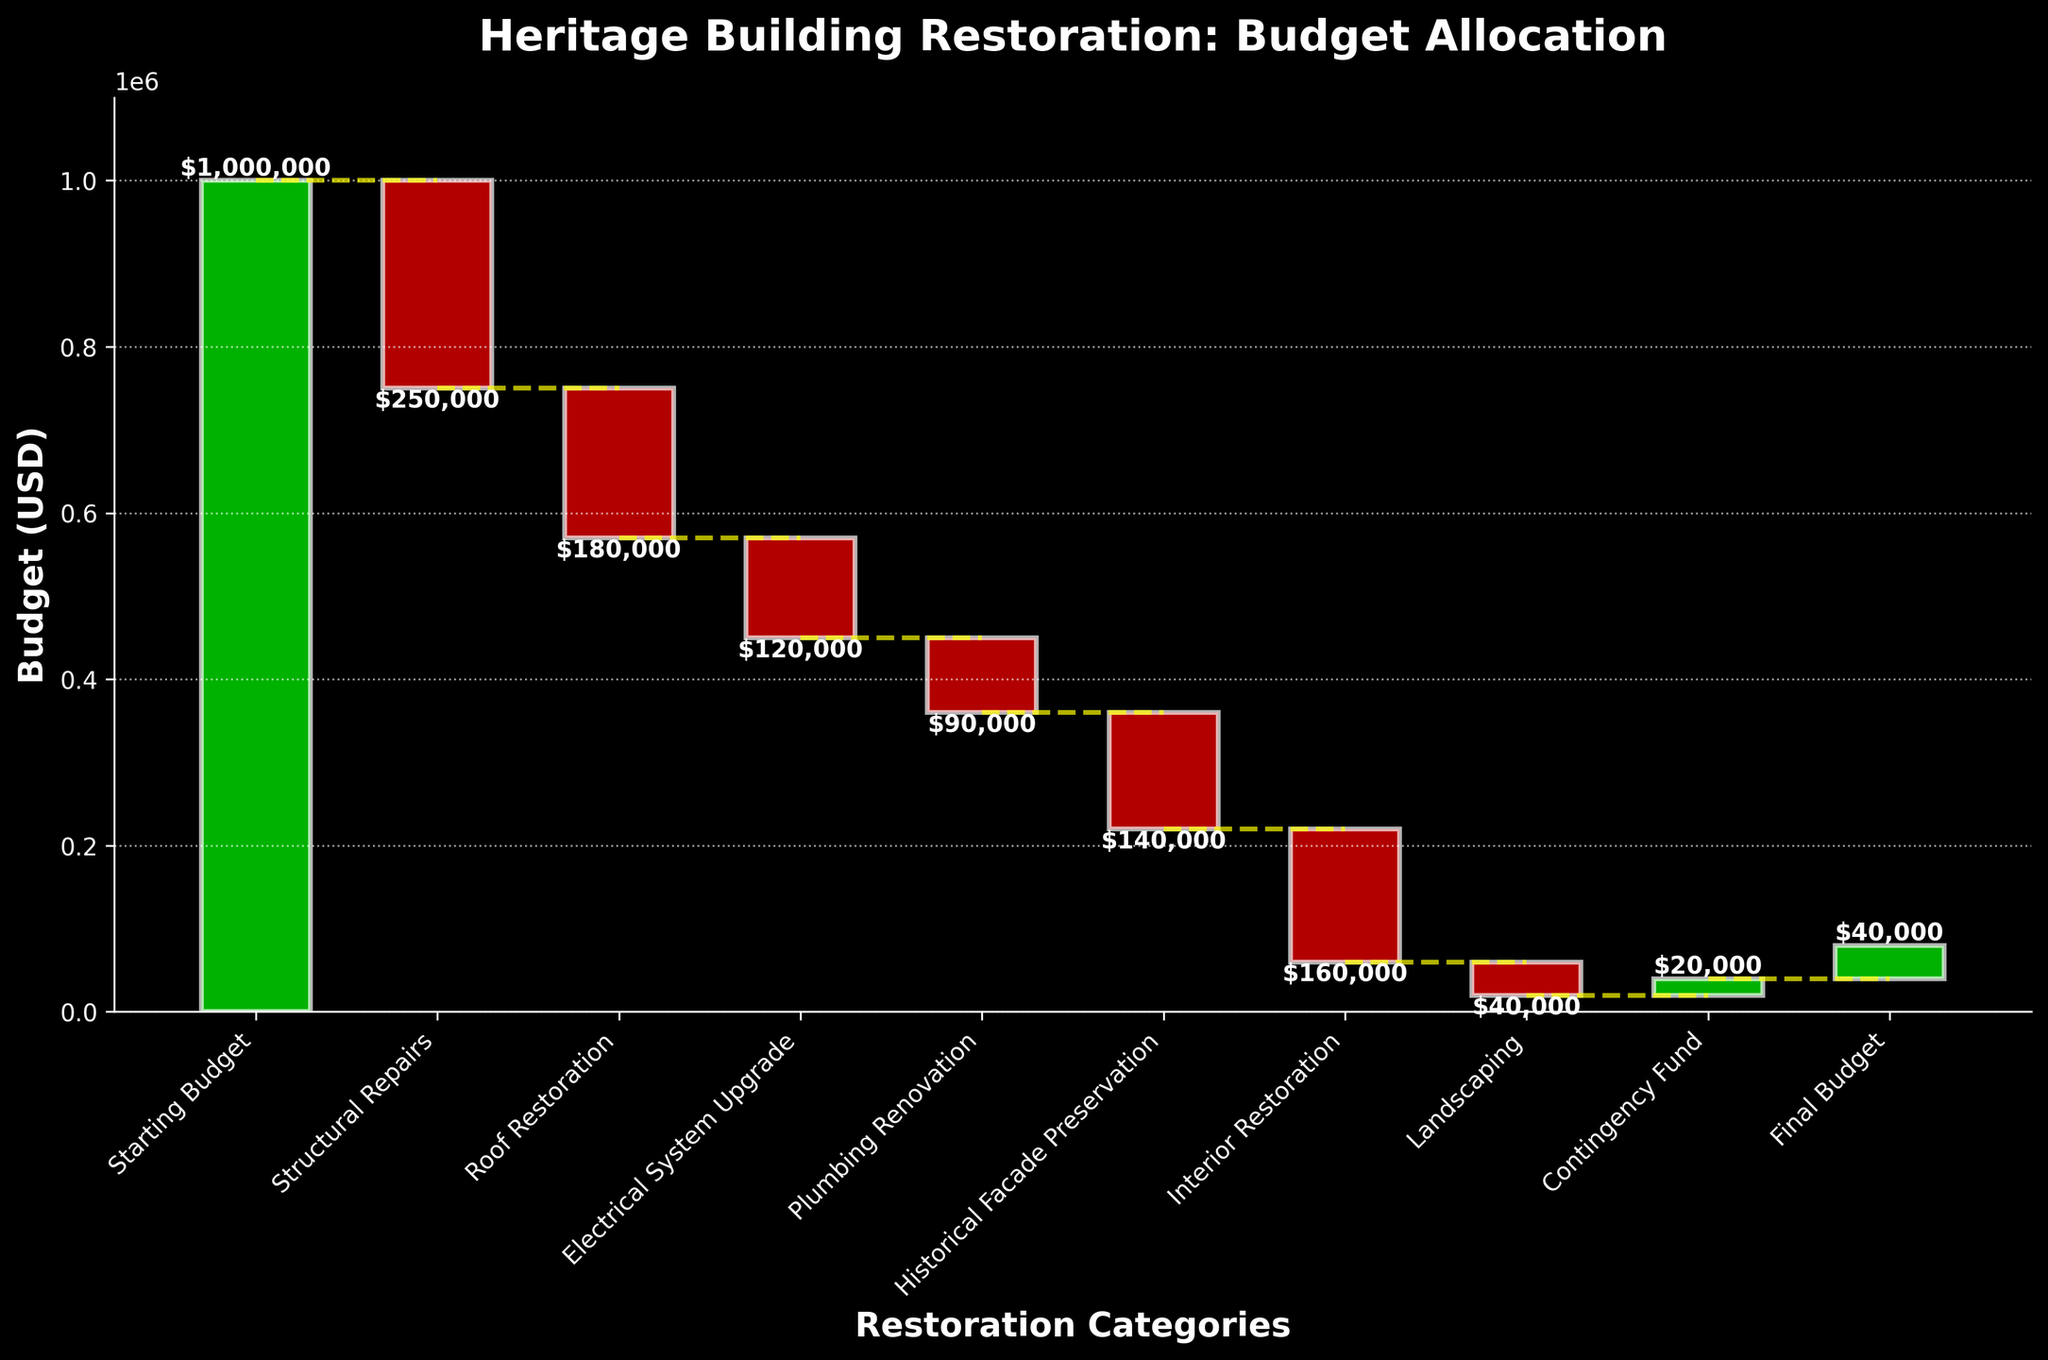What's the title of the chart? The title is usually displayed at the top of the chart. When looking at the chart, you can see the title "Heritage Building Restoration: Budget Allocation".
Answer: Heritage Building Restoration: Budget Allocation What is the value associated with 'Structural Repairs'? Locate 'Structural Repairs' on the x-axis. Follow the corresponding bar, note its height, and the label associated with it. The value is -$250,000.
Answer: -$250,000 What's the total spending on the restoration categories excluding 'Starting Budget' and 'Final Budget'? Sum all the negative values from the categories, excluding 'Starting Budget' and 'Final Budget': (-250,000) + (-180,000) + (-120,000) + (-90,000) + (-140,000) + (-160,000) + (-40,000) = -980,000.
Answer: -$980,000 Which category has the second highest cost reduction after 'Structural Repairs'? By analyzing the heights of the negative bars, 'Structural Repairs' reduces the most. The next highest negative bar is 'Interior Restoration' with -160,000.
Answer: Interior Restoration What is the net change in budget due to contingencies? The chart shows the 'Contingency Fund' category with a positive change of $20,000, indicating an increase in the budget.
Answer: $20,000 What is the final budget and how is it calculated? The final budget is shown at the end of the chart with a bar labeled 'Final Budget'. This value is derived from the starting budget adjusted by all the increases and decreases: $1,000,000 - $980,000 + $20,000 = $40,000.
Answer: $40,000 How much is spent on both 'Roof Restoration' and 'Electrical System Upgrade' combined? Add the values for 'Roof Restoration' and 'Electrical System Upgrade': -180,000 + -120,000 = -300,000.
Answer: -$300,000 Comparing 'Plumbing Renovation' and 'Landscaping', which one had a greater cost and by how much? By comparing the heights of the bars, 'Plumbing Renovation' costs $90,000 and 'Landscaping' costs $40,000. The difference is 90,000 - 40,000 = 50,000.
Answer: Plumbing Renovation by $50,000 What is depicted along the y-axis of the chart? The y-axis of the chart typically represents the budget values in USD. From the marked ticks, it is clear that it shows the budget in dollars.
Answer: Budget (USD) 